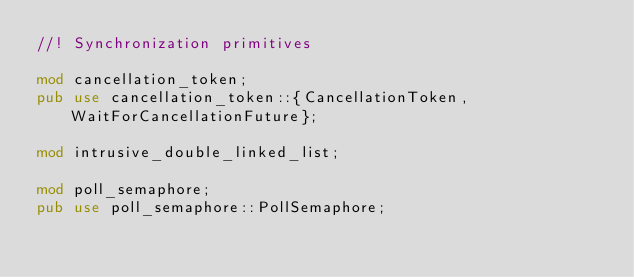Convert code to text. <code><loc_0><loc_0><loc_500><loc_500><_Rust_>//! Synchronization primitives

mod cancellation_token;
pub use cancellation_token::{CancellationToken, WaitForCancellationFuture};

mod intrusive_double_linked_list;

mod poll_semaphore;
pub use poll_semaphore::PollSemaphore;
</code> 